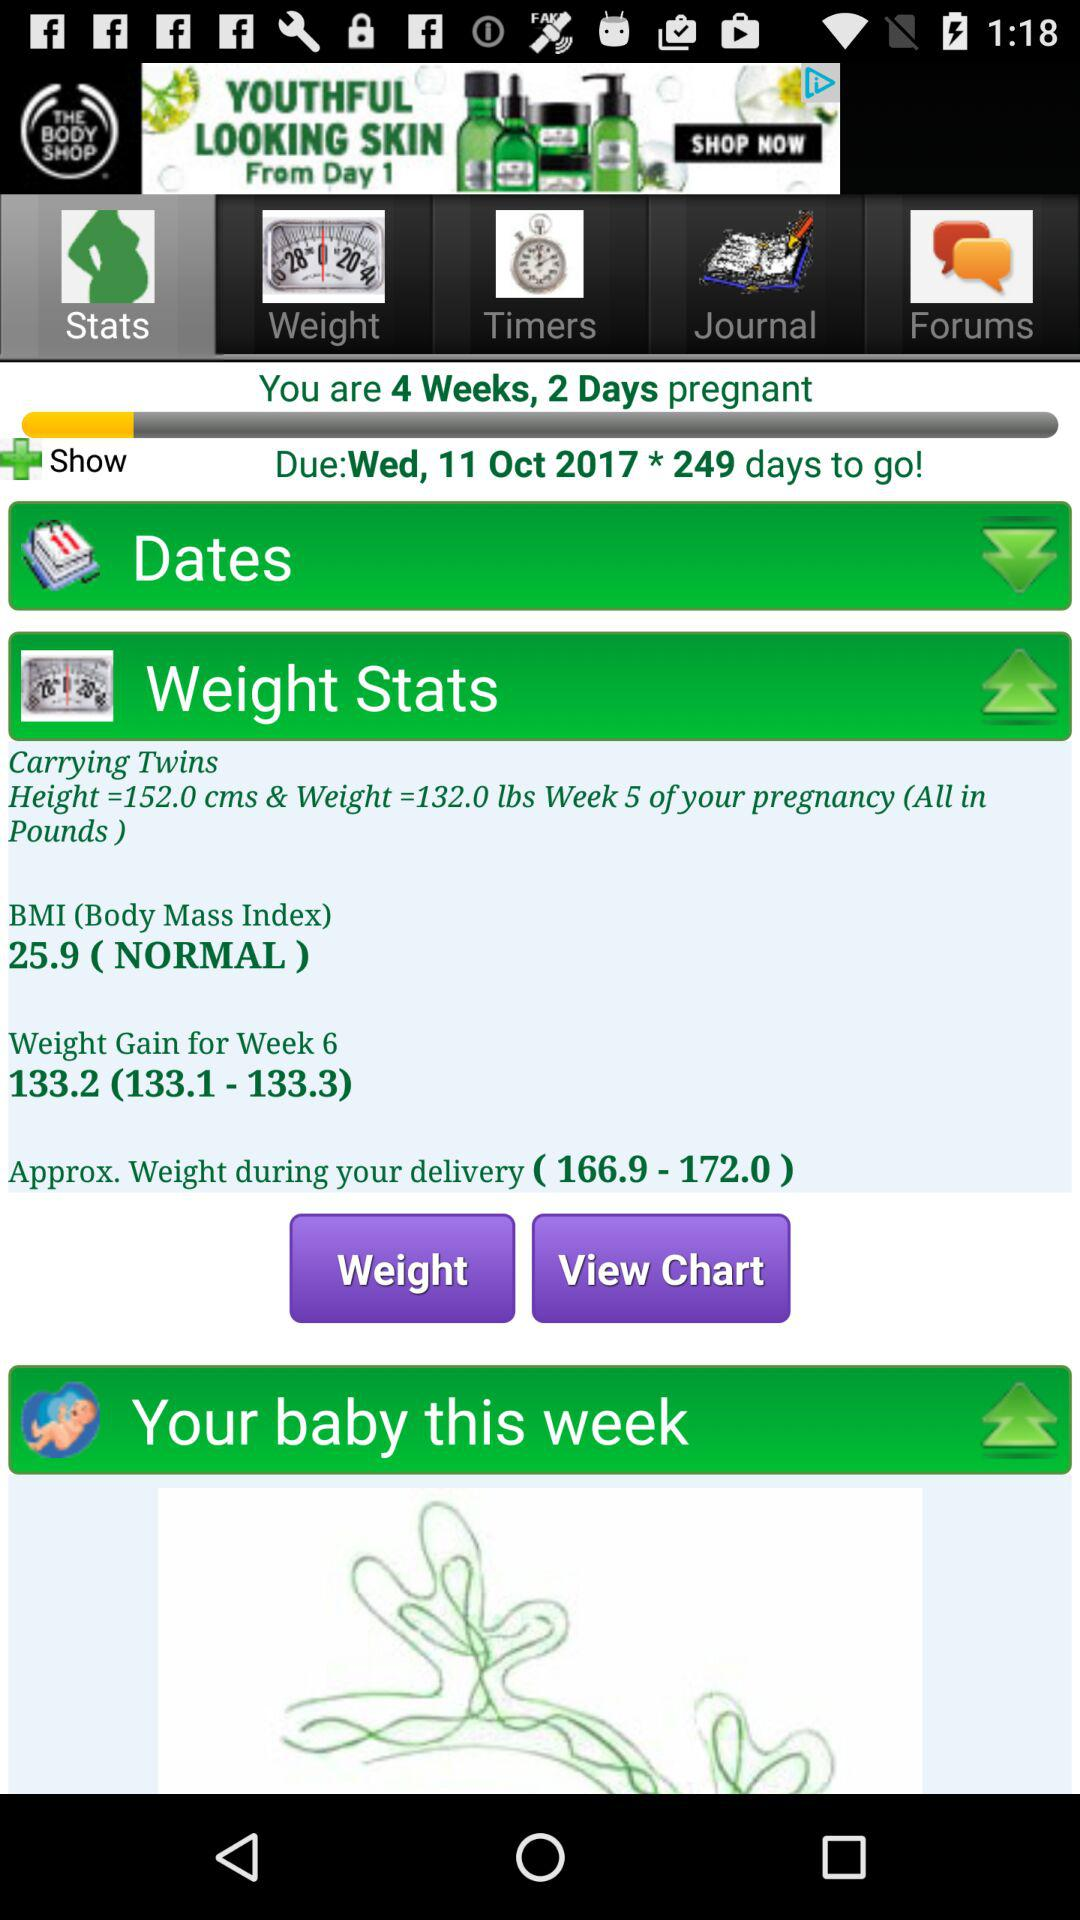What is the BMI? The BMI is normal at 25.9. 